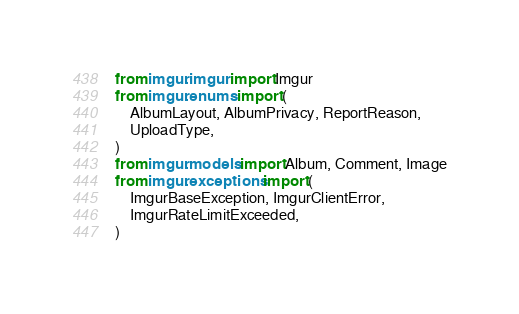Convert code to text. <code><loc_0><loc_0><loc_500><loc_500><_Python_>
from imgur.imgur import Imgur
from imgur.enums import (
    AlbumLayout, AlbumPrivacy, ReportReason,
    UploadType,
)
from imgur.models import Album, Comment, Image
from imgur.exceptions import (
    ImgurBaseException, ImgurClientError,
    ImgurRateLimitExceeded,
)
</code> 